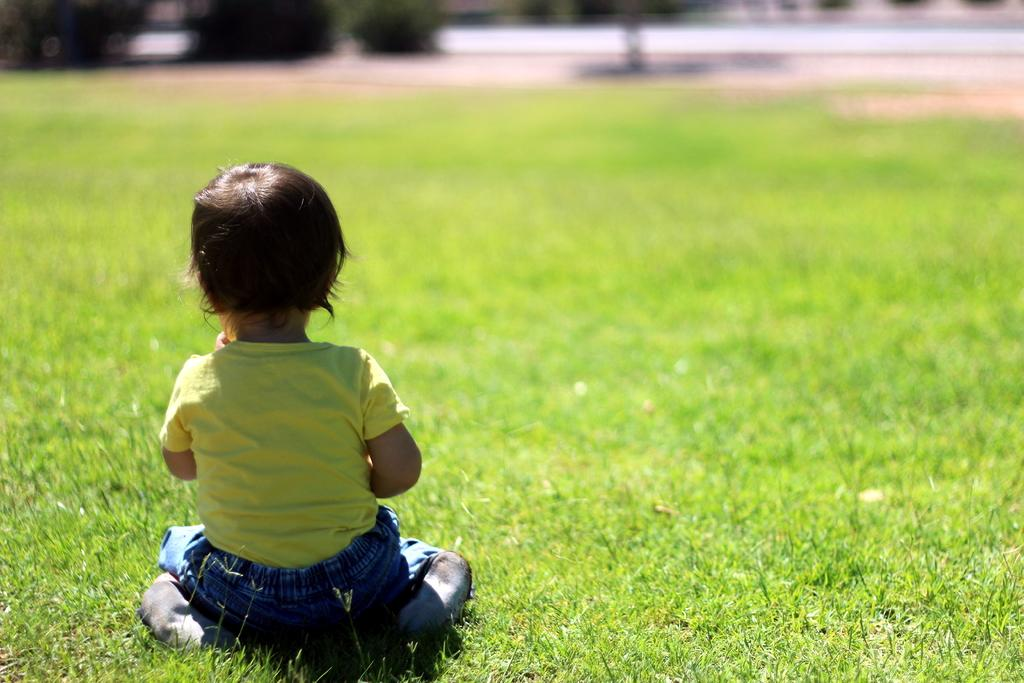Who is the main subject in the image? There is a child in the image. What is the child doing in the image? The child is sitting on the grass. What is the child wearing in the image? The child is wearing a yellow and blue color dress. Can you describe the background of the image? The background of the image is blurred. What type of yarn is being used to create the child's dress in the image? There is no yarn present in the image; the child is wearing a dress made of fabric. How many trucks can be seen in the background of the image? There are no trucks visible in the image; the background is blurred. 